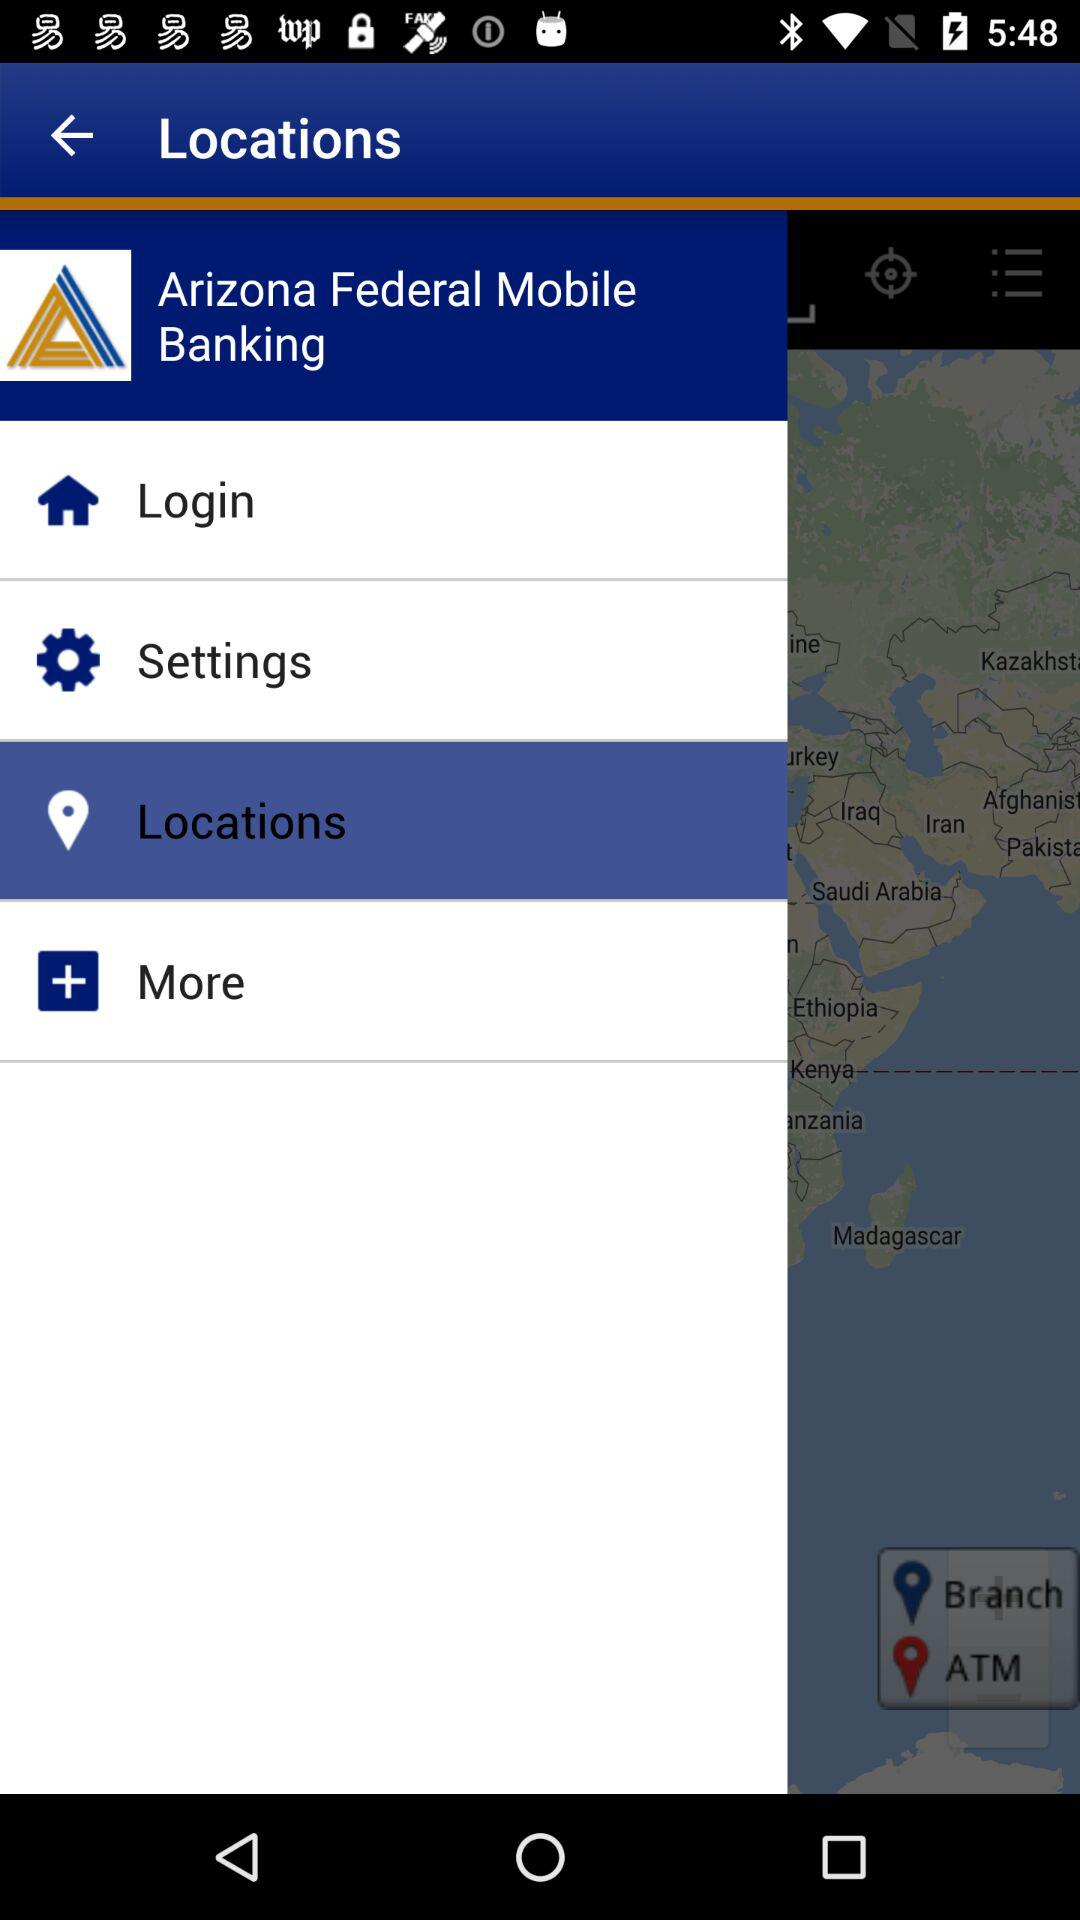What is the state name?
When the provided information is insufficient, respond with <no answer>. <no answer> 